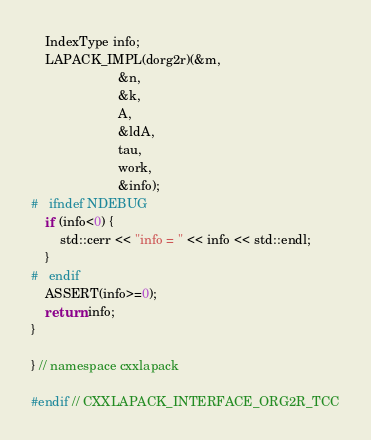<code> <loc_0><loc_0><loc_500><loc_500><_C++_>
    IndexType info;
    LAPACK_IMPL(dorg2r)(&m,
                        &n,
                        &k,
                        A,
                        &ldA,
                        tau,
                        work,
                        &info);
#   ifndef NDEBUG
    if (info<0) {
        std::cerr << "info = " << info << std::endl;
    }
#   endif
    ASSERT(info>=0);
    return info;
}

} // namespace cxxlapack

#endif // CXXLAPACK_INTERFACE_ORG2R_TCC
</code> 